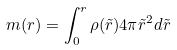Convert formula to latex. <formula><loc_0><loc_0><loc_500><loc_500>m ( r ) = \int _ { 0 } ^ { r } \rho ( \tilde { r } ) 4 \pi \tilde { r } ^ { 2 } d \tilde { r }</formula> 